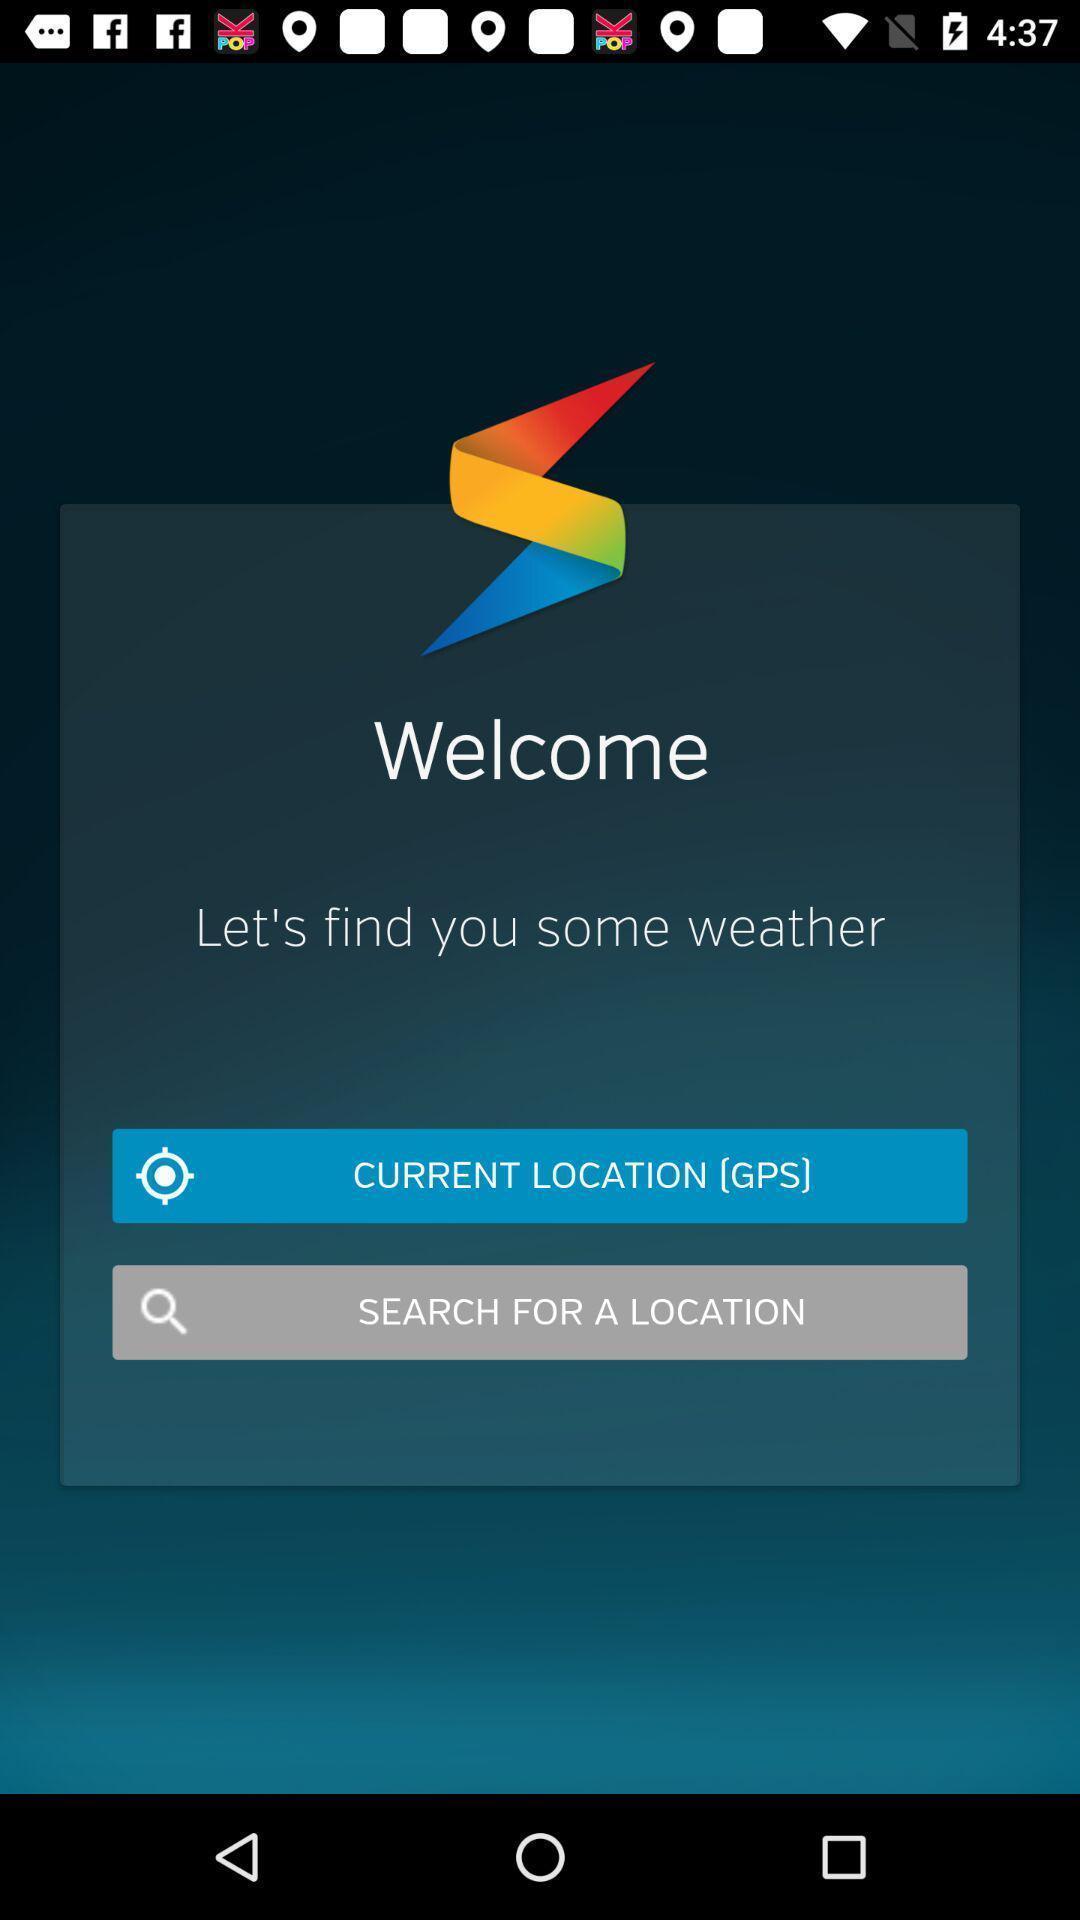Please provide a description for this image. Welcoming page a social app. 